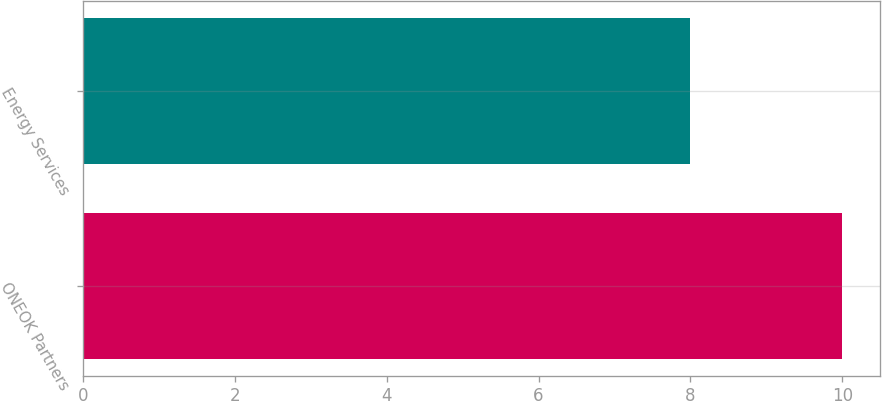Convert chart. <chart><loc_0><loc_0><loc_500><loc_500><bar_chart><fcel>ONEOK Partners<fcel>Energy Services<nl><fcel>10<fcel>8<nl></chart> 